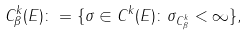Convert formula to latex. <formula><loc_0><loc_0><loc_500><loc_500>C ^ { k } _ { \beta } ( E ) \colon = \{ \sigma \in C ^ { k } ( E ) \colon \| \sigma \| _ { C ^ { k } _ { \beta } } < \infty \} ,</formula> 